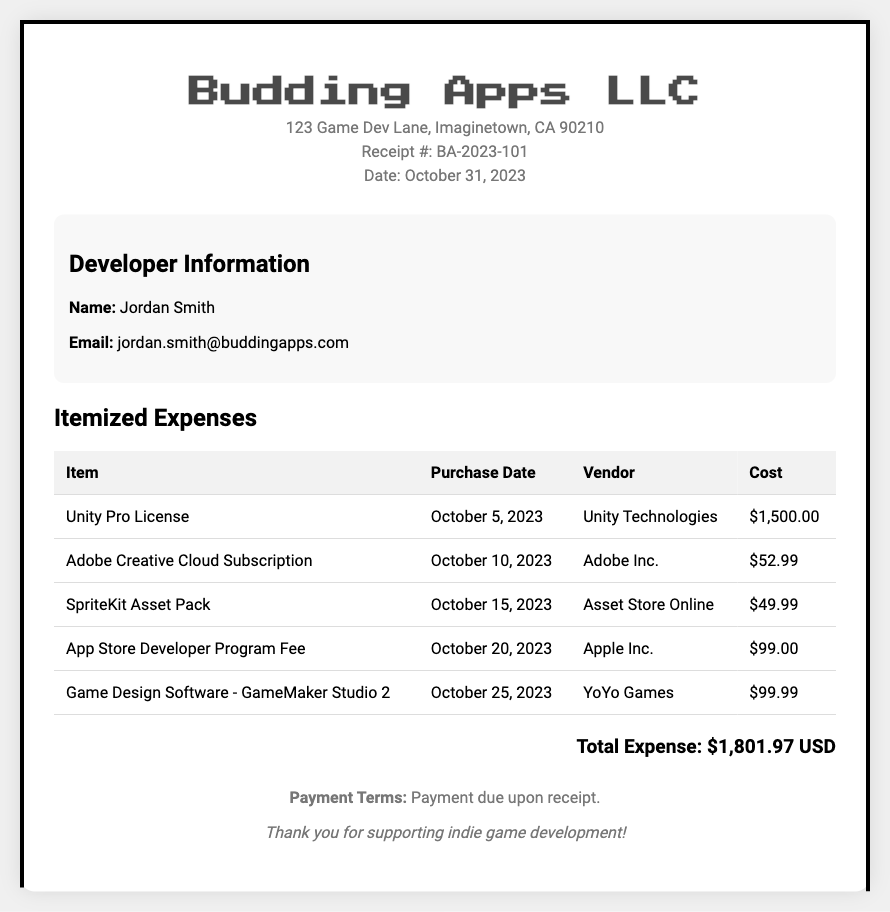What is the receipt number? The receipt number is listed in the document, which is BA-2023-101.
Answer: BA-2023-101 Who is the developer? The developer's name is mentioned in the document, which is Jordan Smith.
Answer: Jordan Smith What is the total expense amount? The total expense is calculated at the end of the itemized list, which is $1,801.97.
Answer: $1,801.97 When was the Unity Pro License purchased? The purchase date for the Unity Pro License is indicated in the table, which is October 5, 2023.
Answer: October 5, 2023 Which vendor provided the SpriteKit Asset Pack? The vendor for the SpriteKit Asset Pack is noted in the document, which is Asset Store Online.
Answer: Asset Store Online What is the cost of the Adobe Creative Cloud Subscription? The cost is mentioned in the itemized table under the cost column, which is $52.99.
Answer: $52.99 How many items were listed in the expense document? The document lists a total of five items in the itemized list.
Answer: 5 What is the payment term stated in the document? The payment term is summarized in the footer of the document as "Payment due upon receipt."
Answer: Payment due upon receipt What was the purpose of the App Store Developer Program Fee? The fee is a charge related specifically to developing apps for the App Store, which is indicated in the document.
Answer: App Store Developer Program Fee 